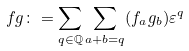<formula> <loc_0><loc_0><loc_500><loc_500>f g \colon = \sum _ { q \in \mathbb { Q } } \sum _ { a + b = q } ( f _ { a } g _ { b } ) \varepsilon ^ { q }</formula> 